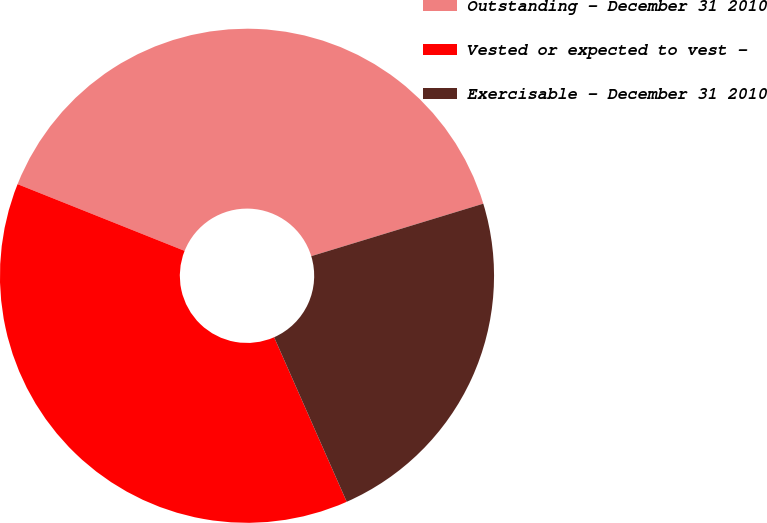<chart> <loc_0><loc_0><loc_500><loc_500><pie_chart><fcel>Outstanding - December 31 2010<fcel>Vested or expected to vest -<fcel>Exercisable - December 31 2010<nl><fcel>39.24%<fcel>37.66%<fcel>23.1%<nl></chart> 